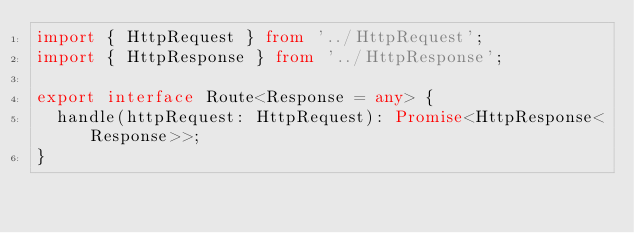<code> <loc_0><loc_0><loc_500><loc_500><_TypeScript_>import { HttpRequest } from '../HttpRequest';
import { HttpResponse } from '../HttpResponse';

export interface Route<Response = any> {
  handle(httpRequest: HttpRequest): Promise<HttpResponse<Response>>;
}
</code> 